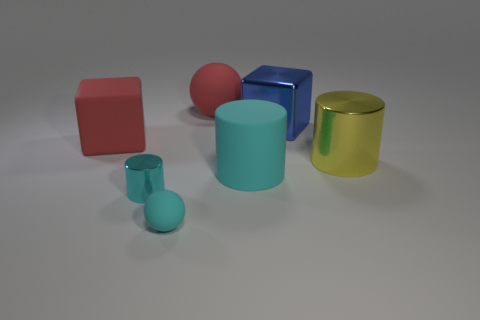What size is the yellow object that is the same material as the large blue object?
Offer a terse response. Large. Does the blue metallic block have the same size as the sphere in front of the big yellow cylinder?
Your answer should be very brief. No. There is a metal thing that is both in front of the big red rubber cube and right of the small cyan metal cylinder; what color is it?
Your answer should be compact. Yellow. What number of things are big red matte things right of the red matte cube or red things behind the large blue metallic cube?
Offer a terse response. 1. What is the color of the cube that is on the right side of the large ball behind the large metal thing in front of the blue block?
Provide a short and direct response. Blue. Is there a matte object of the same shape as the tiny metal thing?
Provide a succinct answer. Yes. What number of cylinders are there?
Provide a succinct answer. 3. What is the shape of the large yellow thing?
Provide a succinct answer. Cylinder. What number of other cubes have the same size as the blue cube?
Give a very brief answer. 1. Does the small cyan matte object have the same shape as the tiny cyan shiny object?
Provide a short and direct response. No. 